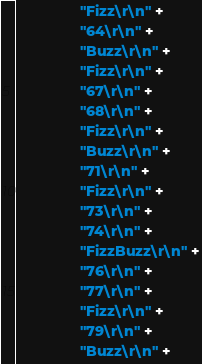Convert code to text. <code><loc_0><loc_0><loc_500><loc_500><_Java_>                "Fizz\r\n" +
                "64\r\n" +
                "Buzz\r\n" +
                "Fizz\r\n" +
                "67\r\n" +
                "68\r\n" +
                "Fizz\r\n" +
                "Buzz\r\n" +
                "71\r\n" +
                "Fizz\r\n" +
                "73\r\n" +
                "74\r\n" +
                "FizzBuzz\r\n" +
                "76\r\n" +
                "77\r\n" +
                "Fizz\r\n" +
                "79\r\n" +
                "Buzz\r\n" +</code> 